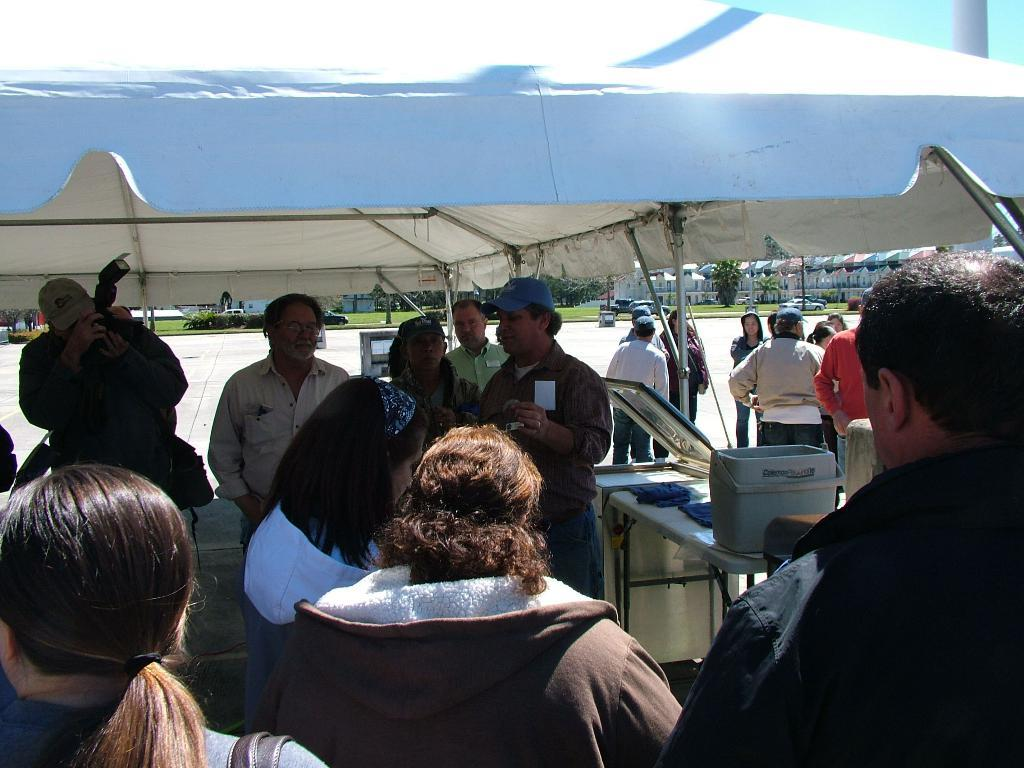How many people are in the image? There is a group of people in the image, but the exact number cannot be determined from the provided facts. What type of temporary shelters can be seen in the image? There are tents in the image. What is on the table in the image? There is a box on the table in the image. What can be seen in the background of the image? There are trees, grass, and houses in the background of the image. What type of government is depicted in the image? There is no indication of any government or political entity in the image. Can you tell me how much gold is present in the image? There is no gold present in the image. 